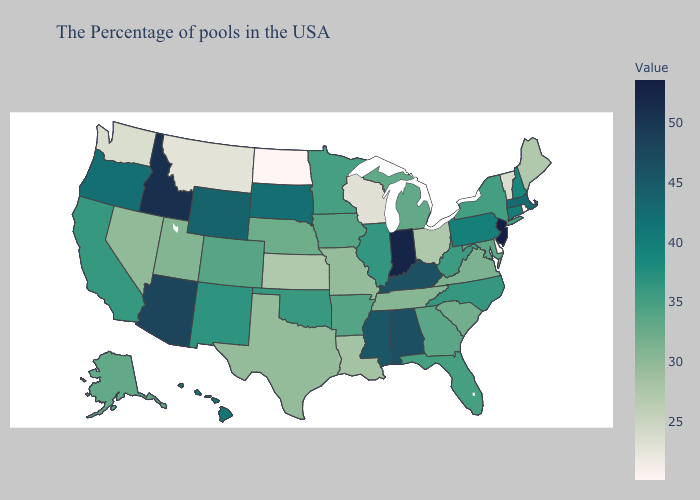Does Arizona have the lowest value in the USA?
Write a very short answer. No. Does Mississippi have the lowest value in the USA?
Concise answer only. No. Does Iowa have a higher value than South Dakota?
Give a very brief answer. No. Does Idaho have the highest value in the West?
Answer briefly. Yes. Among the states that border Indiana , does Michigan have the highest value?
Write a very short answer. No. Does California have a higher value than Montana?
Give a very brief answer. Yes. 